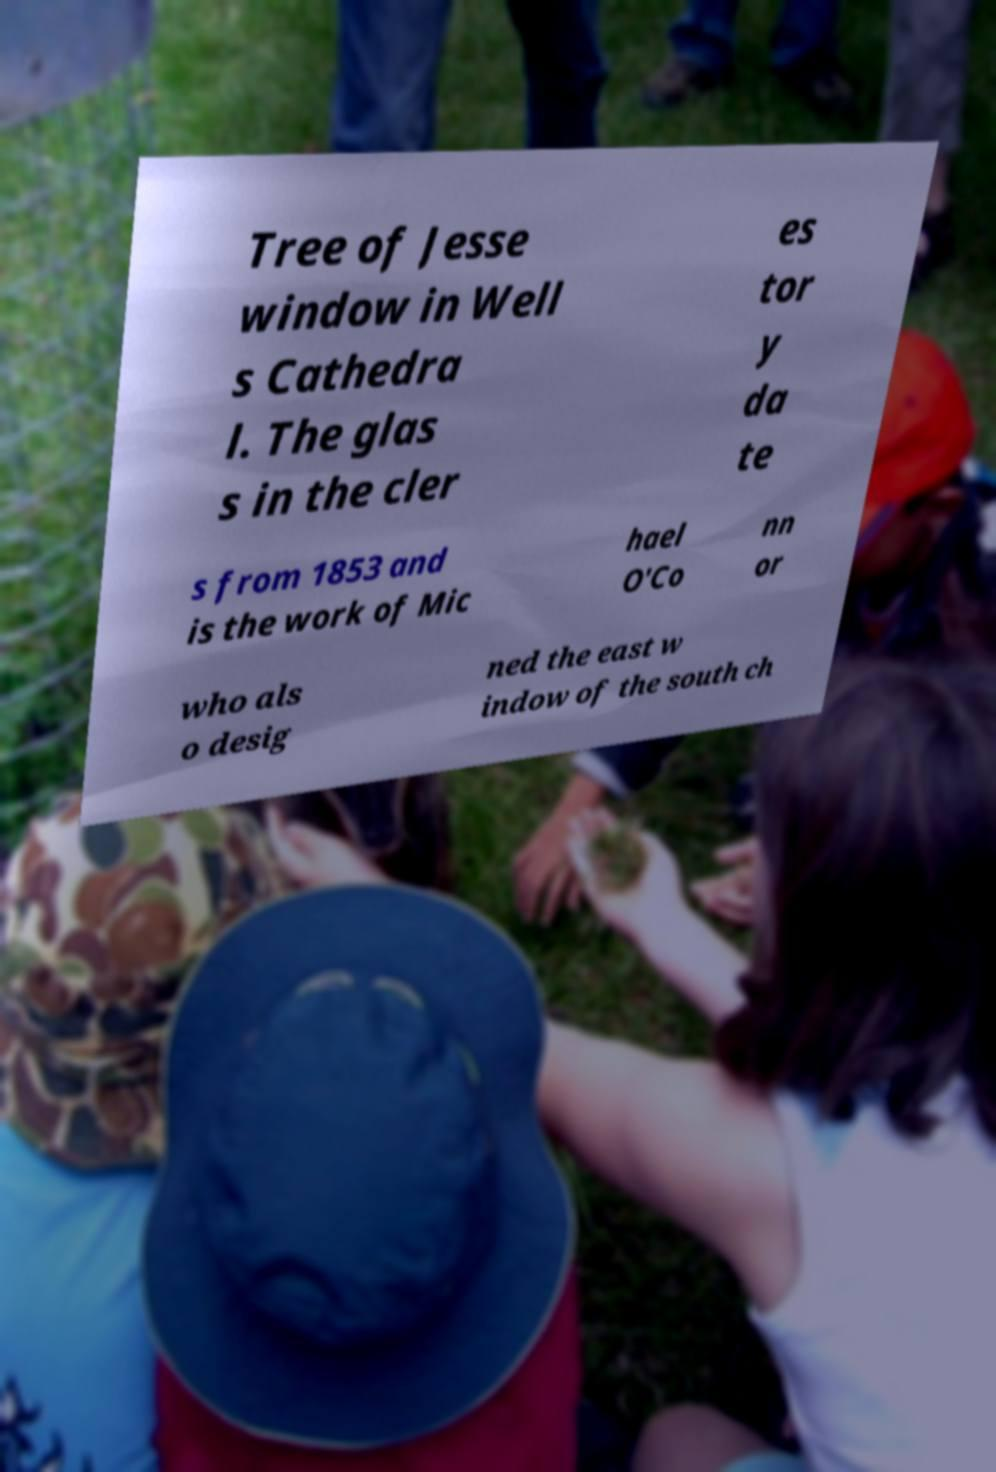Can you accurately transcribe the text from the provided image for me? Tree of Jesse window in Well s Cathedra l. The glas s in the cler es tor y da te s from 1853 and is the work of Mic hael O'Co nn or who als o desig ned the east w indow of the south ch 